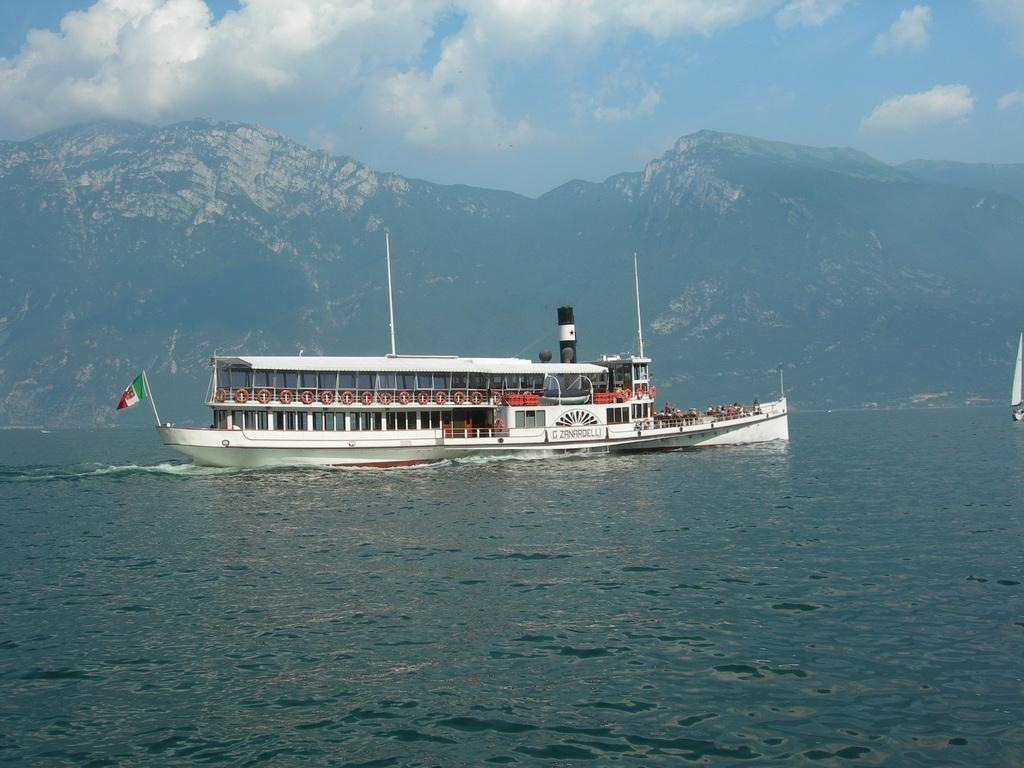What type of vehicle is in the image? There is a white color ship in the image. What is attached to the ship? There is a flag in the image. What is the ship floating on? Water is visible in the image. What type of landscape can be seen in the background? Mountains are present in the image. What colors can be seen in the sky? The sky is a combination of white and blue colors. What type of scent can be detected coming from the ship in the image? There is no information about scents in the image, so it cannot be determined. 